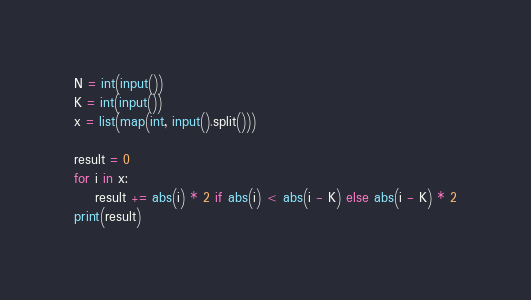<code> <loc_0><loc_0><loc_500><loc_500><_Python_>N = int(input())
K = int(input())
x = list(map(int, input().split()))

result = 0
for i in x:
    result += abs(i) * 2 if abs(i) < abs(i - K) else abs(i - K) * 2
print(result)
</code> 